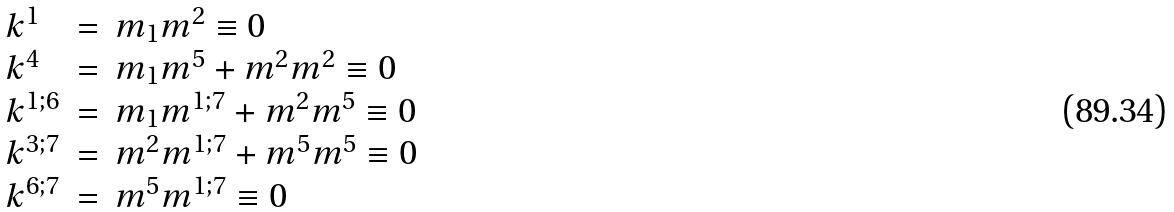<formula> <loc_0><loc_0><loc_500><loc_500>\begin{array} { l l l } k ^ { 1 } & = & m _ { 1 } m ^ { 2 } \equiv 0 \\ k ^ { 4 } & = & m _ { 1 } m ^ { 5 } + m ^ { 2 } m ^ { 2 } \equiv 0 \\ k ^ { 1 ; 6 } & = & m _ { 1 } m ^ { 1 ; 7 } + m ^ { 2 } m ^ { 5 } \equiv 0 \\ k ^ { 3 ; 7 } & = & m ^ { 2 } m ^ { 1 ; 7 } + m ^ { 5 } m ^ { 5 } \equiv 0 \\ k ^ { 6 ; 7 } & = & m ^ { 5 } m ^ { 1 ; 7 } \equiv 0 \end{array}</formula> 